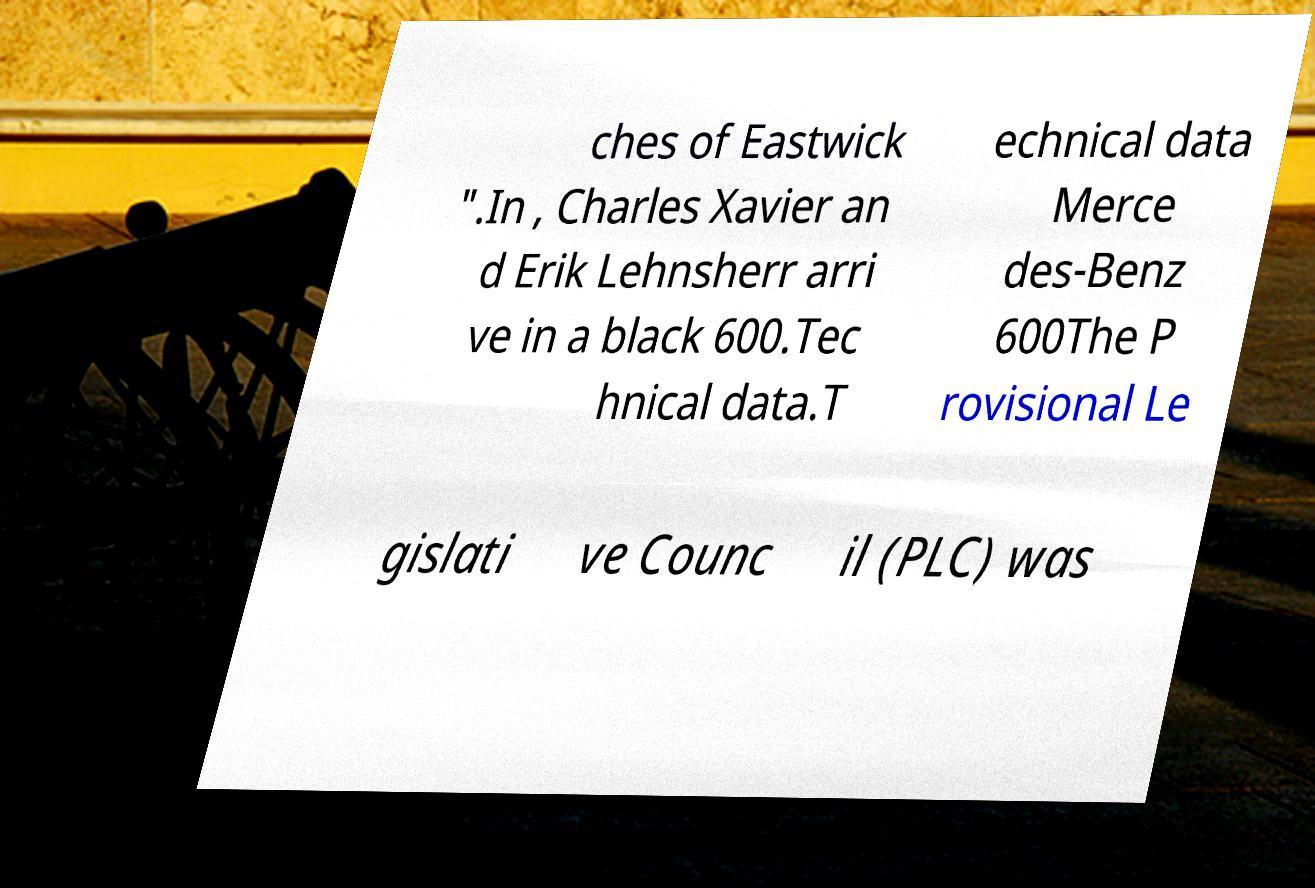Can you accurately transcribe the text from the provided image for me? ches of Eastwick ".In , Charles Xavier an d Erik Lehnsherr arri ve in a black 600.Tec hnical data.T echnical data Merce des-Benz 600The P rovisional Le gislati ve Counc il (PLC) was 